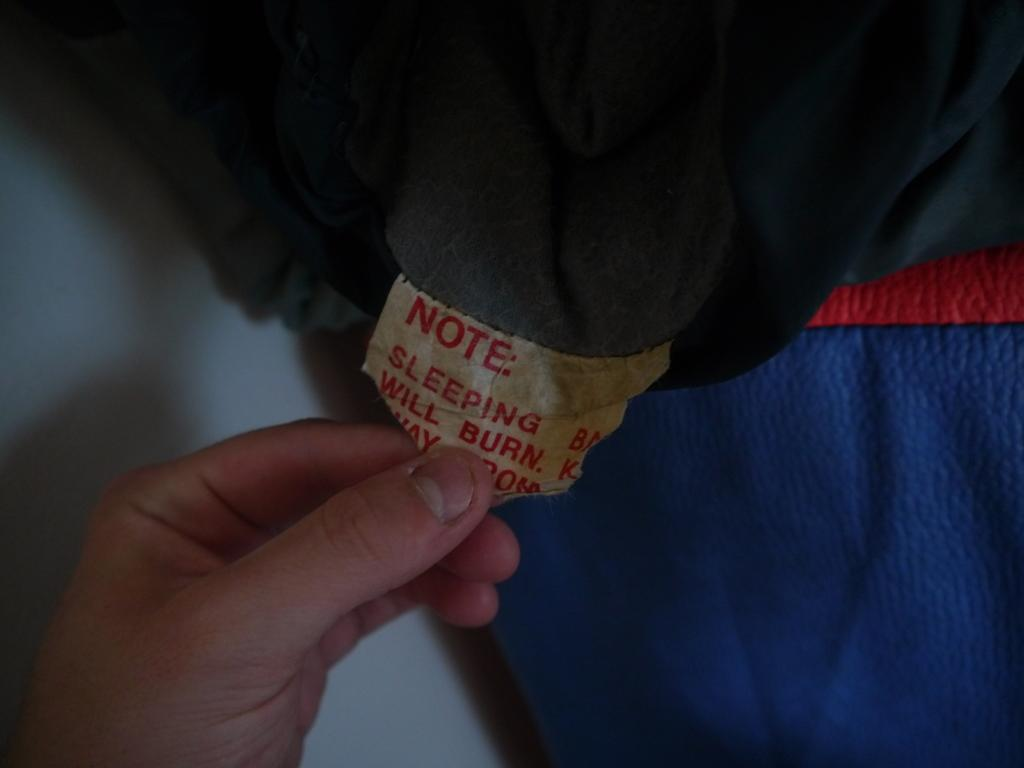What part of a person is visible in the image? There is a person's hand in the image. What is the hand holding? The hand is holding a tag. What is the tag attached to? The tag is attached to a cloth. Where in the image are the hand and tag located? The hand and tag are located at the bottom of the image. What type of flower is growing in the hand in the image? There is no flower present in the image; the hand is holding a tag attached to a cloth. 